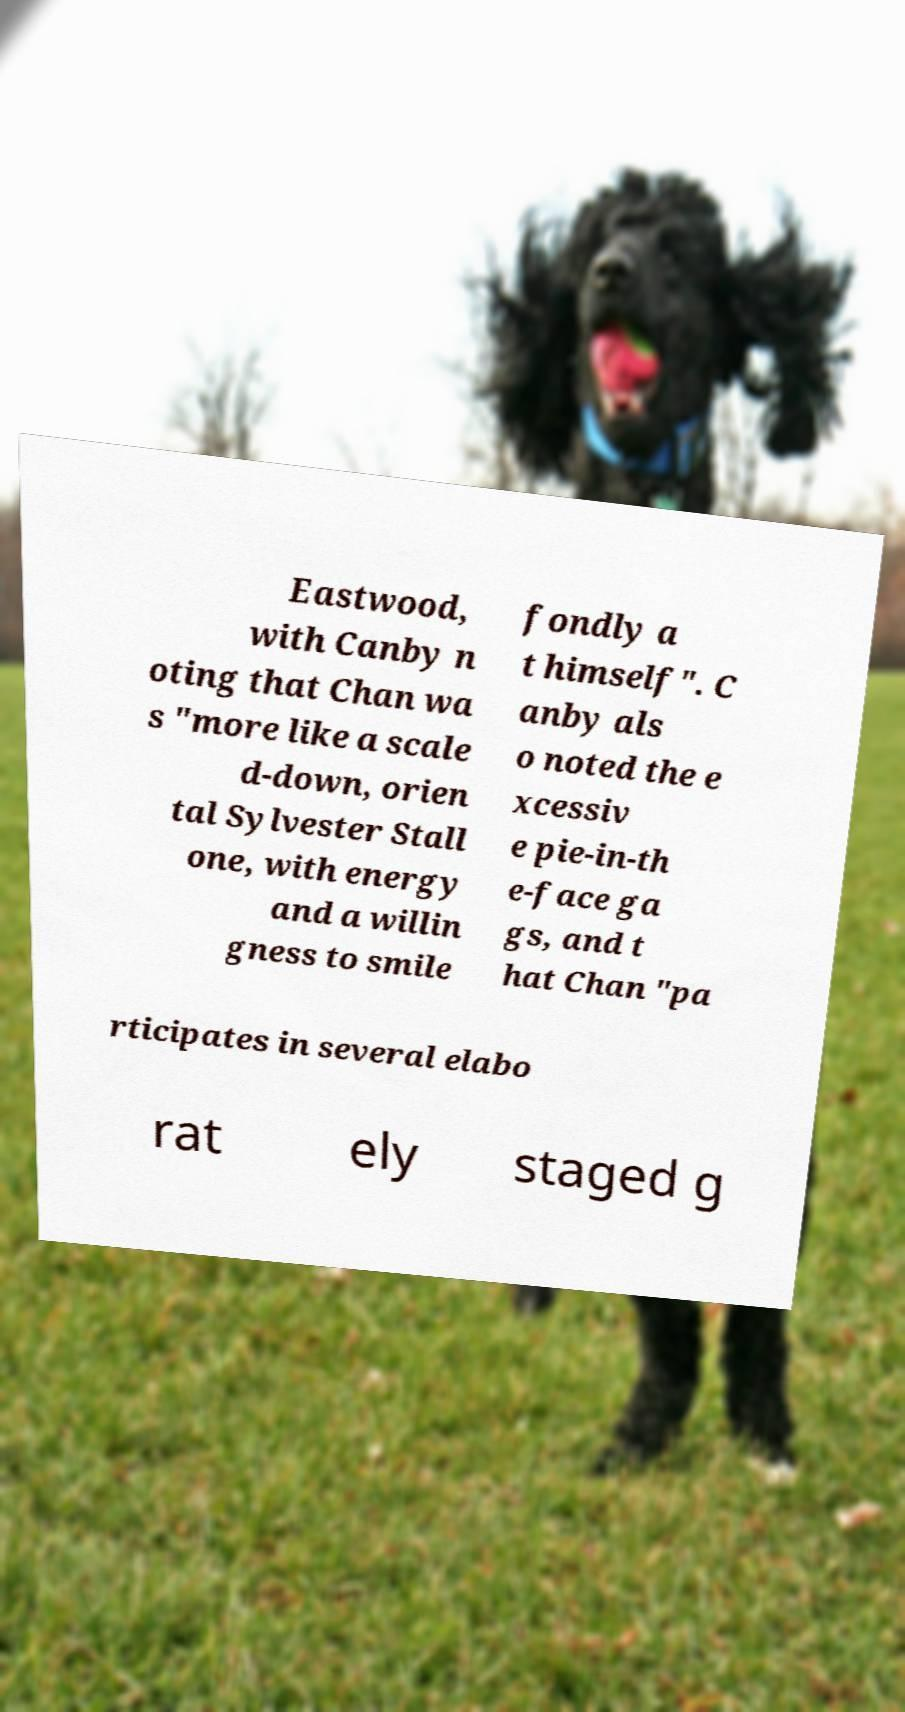What messages or text are displayed in this image? I need them in a readable, typed format. Eastwood, with Canby n oting that Chan wa s "more like a scale d-down, orien tal Sylvester Stall one, with energy and a willin gness to smile fondly a t himself". C anby als o noted the e xcessiv e pie-in-th e-face ga gs, and t hat Chan "pa rticipates in several elabo rat ely staged g 